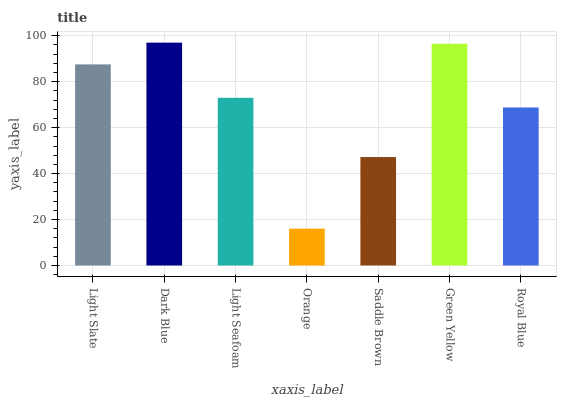Is Orange the minimum?
Answer yes or no. Yes. Is Dark Blue the maximum?
Answer yes or no. Yes. Is Light Seafoam the minimum?
Answer yes or no. No. Is Light Seafoam the maximum?
Answer yes or no. No. Is Dark Blue greater than Light Seafoam?
Answer yes or no. Yes. Is Light Seafoam less than Dark Blue?
Answer yes or no. Yes. Is Light Seafoam greater than Dark Blue?
Answer yes or no. No. Is Dark Blue less than Light Seafoam?
Answer yes or no. No. Is Light Seafoam the high median?
Answer yes or no. Yes. Is Light Seafoam the low median?
Answer yes or no. Yes. Is Orange the high median?
Answer yes or no. No. Is Green Yellow the low median?
Answer yes or no. No. 